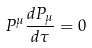Convert formula to latex. <formula><loc_0><loc_0><loc_500><loc_500>P ^ { \mu } \frac { d P _ { \mu } } { d \tau } = 0</formula> 